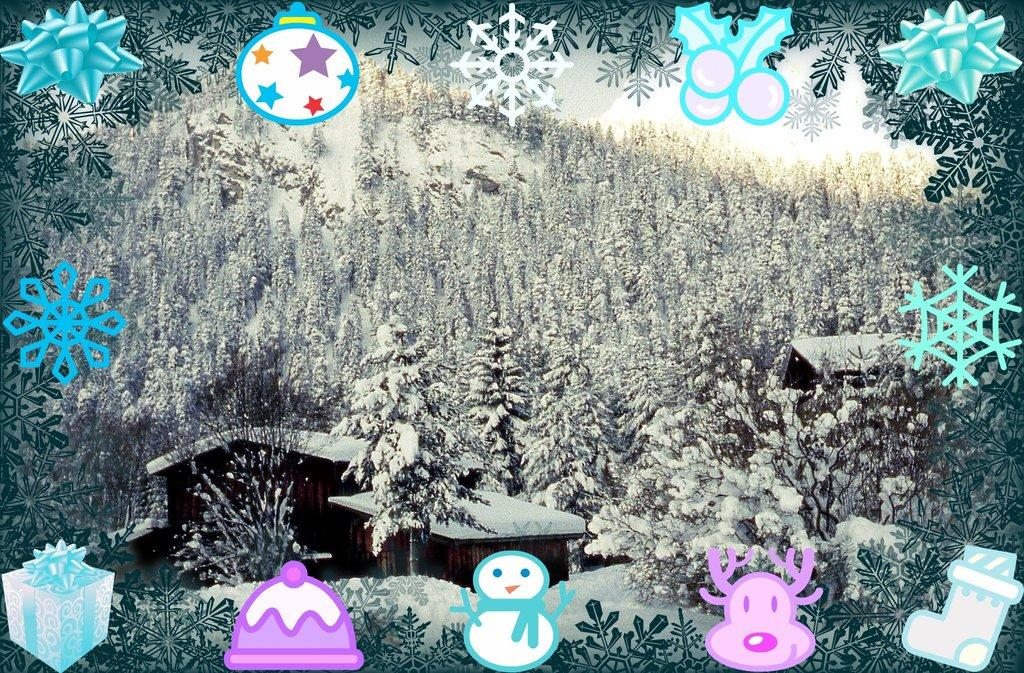What type of image is being described? The image is graphical in nature. What natural elements can be seen in the image? There are trees in the image. What man-made structure is present in the image? There is a house in the image. What weather condition is depicted in the image? There is snow visible in the image. What type of skirt is being worn by the industry in the image? There is no industry or skirt present in the image. Who is the partner of the house in the image? The image does not depict any people or relationships, so there is no partner for the house. 